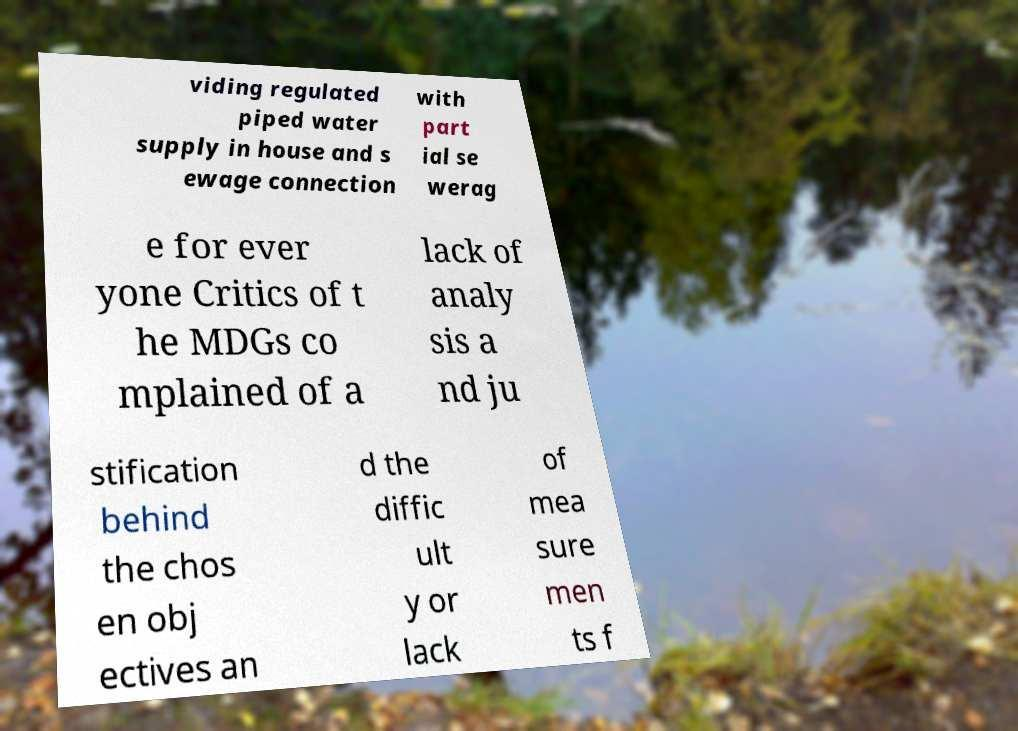What messages or text are displayed in this image? I need them in a readable, typed format. viding regulated piped water supply in house and s ewage connection with part ial se werag e for ever yone Critics of t he MDGs co mplained of a lack of analy sis a nd ju stification behind the chos en obj ectives an d the diffic ult y or lack of mea sure men ts f 